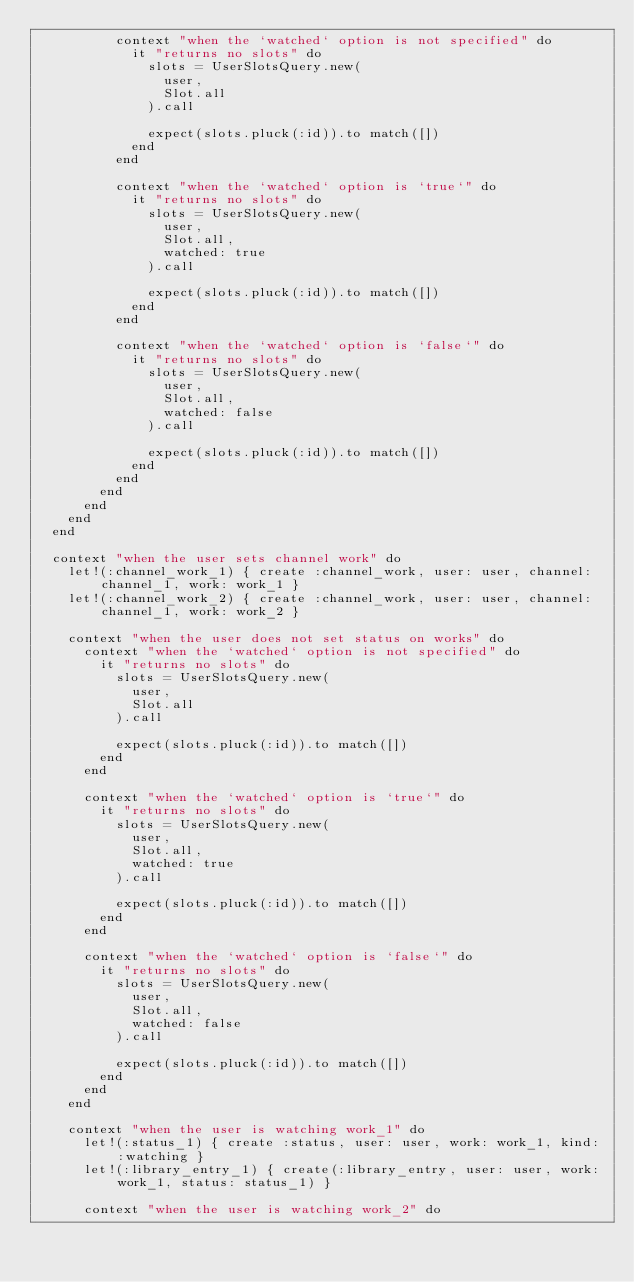Convert code to text. <code><loc_0><loc_0><loc_500><loc_500><_Ruby_>          context "when the `watched` option is not specified" do
            it "returns no slots" do
              slots = UserSlotsQuery.new(
                user,
                Slot.all
              ).call

              expect(slots.pluck(:id)).to match([])
            end
          end

          context "when the `watched` option is `true`" do
            it "returns no slots" do
              slots = UserSlotsQuery.new(
                user,
                Slot.all,
                watched: true
              ).call

              expect(slots.pluck(:id)).to match([])
            end
          end

          context "when the `watched` option is `false`" do
            it "returns no slots" do
              slots = UserSlotsQuery.new(
                user,
                Slot.all,
                watched: false
              ).call

              expect(slots.pluck(:id)).to match([])
            end
          end
        end
      end
    end
  end

  context "when the user sets channel work" do
    let!(:channel_work_1) { create :channel_work, user: user, channel: channel_1, work: work_1 }
    let!(:channel_work_2) { create :channel_work, user: user, channel: channel_1, work: work_2 }

    context "when the user does not set status on works" do
      context "when the `watched` option is not specified" do
        it "returns no slots" do
          slots = UserSlotsQuery.new(
            user,
            Slot.all
          ).call

          expect(slots.pluck(:id)).to match([])
        end
      end

      context "when the `watched` option is `true`" do
        it "returns no slots" do
          slots = UserSlotsQuery.new(
            user,
            Slot.all,
            watched: true
          ).call

          expect(slots.pluck(:id)).to match([])
        end
      end

      context "when the `watched` option is `false`" do
        it "returns no slots" do
          slots = UserSlotsQuery.new(
            user,
            Slot.all,
            watched: false
          ).call

          expect(slots.pluck(:id)).to match([])
        end
      end
    end

    context "when the user is watching work_1" do
      let!(:status_1) { create :status, user: user, work: work_1, kind: :watching }
      let!(:library_entry_1) { create(:library_entry, user: user, work: work_1, status: status_1) }

      context "when the user is watching work_2" do</code> 